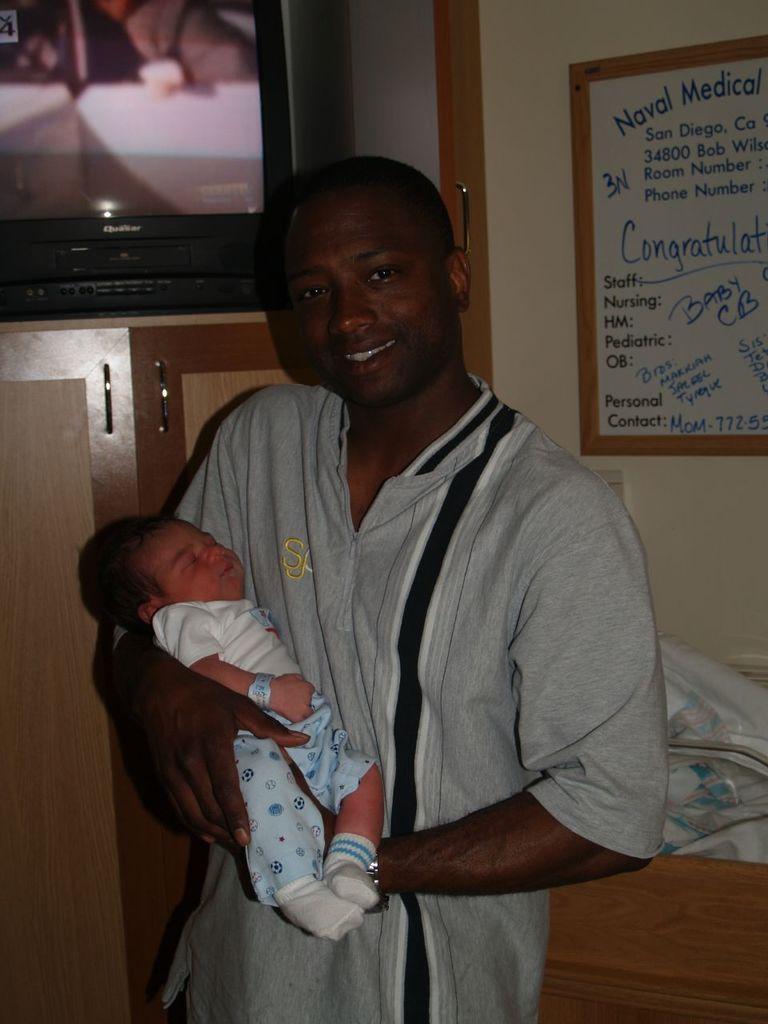How would you summarize this image in a sentence or two? In this image there is a man standing and holding baby in hands, behind him there is a TV in the shelf and also board in the wall. 